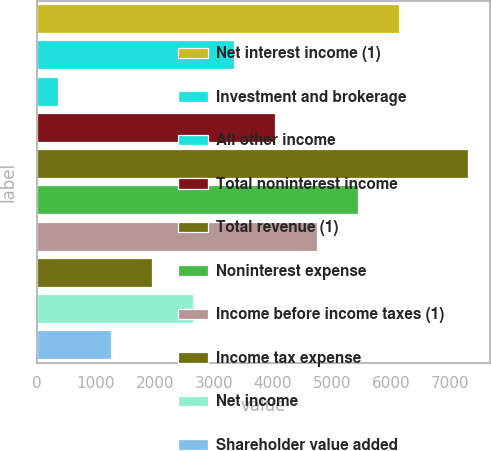Convert chart. <chart><loc_0><loc_0><loc_500><loc_500><bar_chart><fcel>Net interest income (1)<fcel>Investment and brokerage<fcel>All other income<fcel>Total noninterest income<fcel>Total revenue (1)<fcel>Noninterest expense<fcel>Income before income taxes (1)<fcel>Income tax expense<fcel>Net income<fcel>Shareholder value added<nl><fcel>6135<fcel>3351<fcel>356<fcel>4047<fcel>7316<fcel>5439<fcel>4743<fcel>1959<fcel>2655<fcel>1263<nl></chart> 